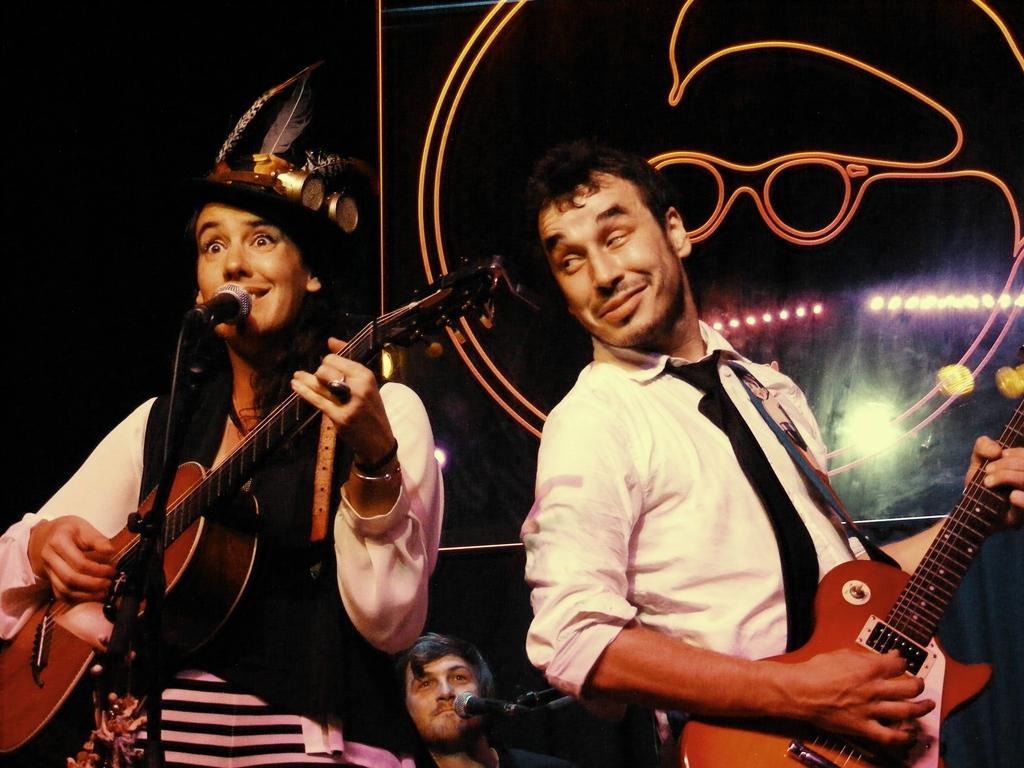Describe this image in one or two sentences. In this image I can see two people are standing and holding guitars, I can also smile on their faces. In the background I can see one more person and also I can see mics. 